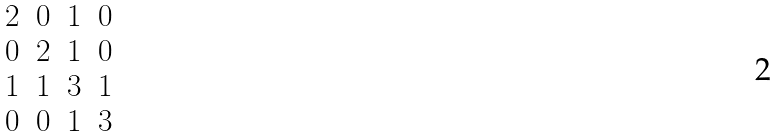<formula> <loc_0><loc_0><loc_500><loc_500>\begin{matrix} 2 & 0 & 1 & 0 \\ 0 & 2 & 1 & 0 \\ 1 & 1 & 3 & 1 \\ 0 & 0 & 1 & 3 \end{matrix}</formula> 